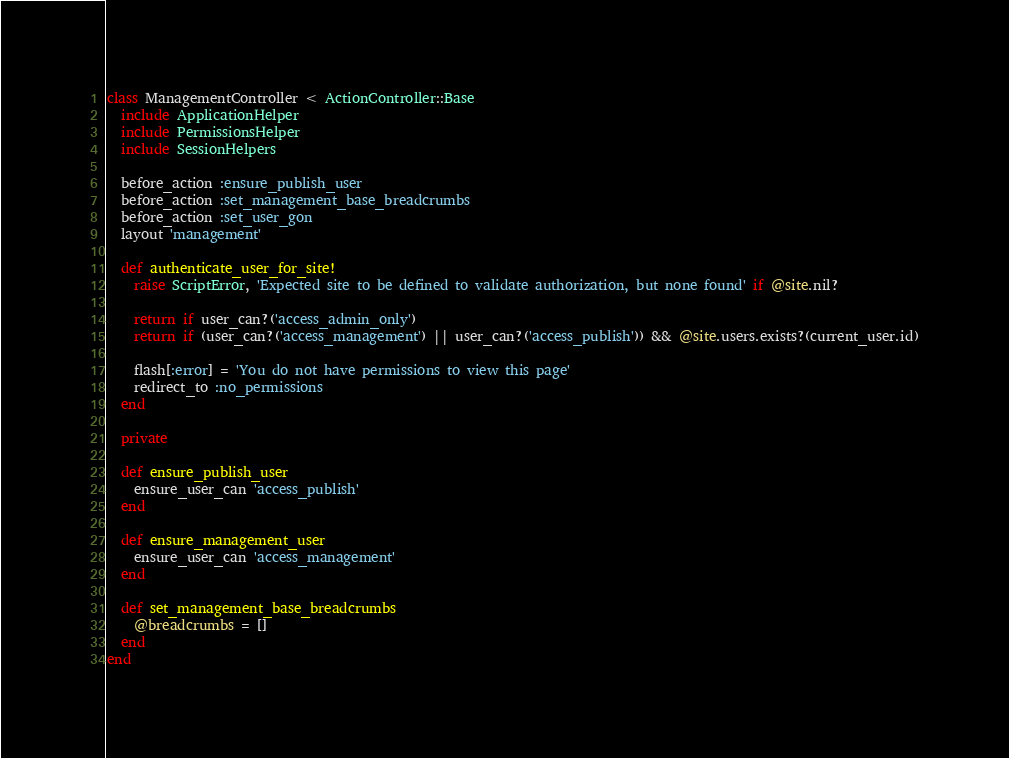<code> <loc_0><loc_0><loc_500><loc_500><_Ruby_>class ManagementController < ActionController::Base
  include ApplicationHelper
  include PermissionsHelper
  include SessionHelpers

  before_action :ensure_publish_user
  before_action :set_management_base_breadcrumbs
  before_action :set_user_gon
  layout 'management'

  def authenticate_user_for_site!
    raise ScriptError, 'Expected site to be defined to validate authorization, but none found' if @site.nil?

    return if user_can?('access_admin_only')
    return if (user_can?('access_management') || user_can?('access_publish')) && @site.users.exists?(current_user.id)

    flash[:error] = 'You do not have permissions to view this page'
    redirect_to :no_permissions
  end

  private

  def ensure_publish_user
    ensure_user_can 'access_publish'
  end

  def ensure_management_user
    ensure_user_can 'access_management'
  end

  def set_management_base_breadcrumbs
    @breadcrumbs = []
  end
end
</code> 